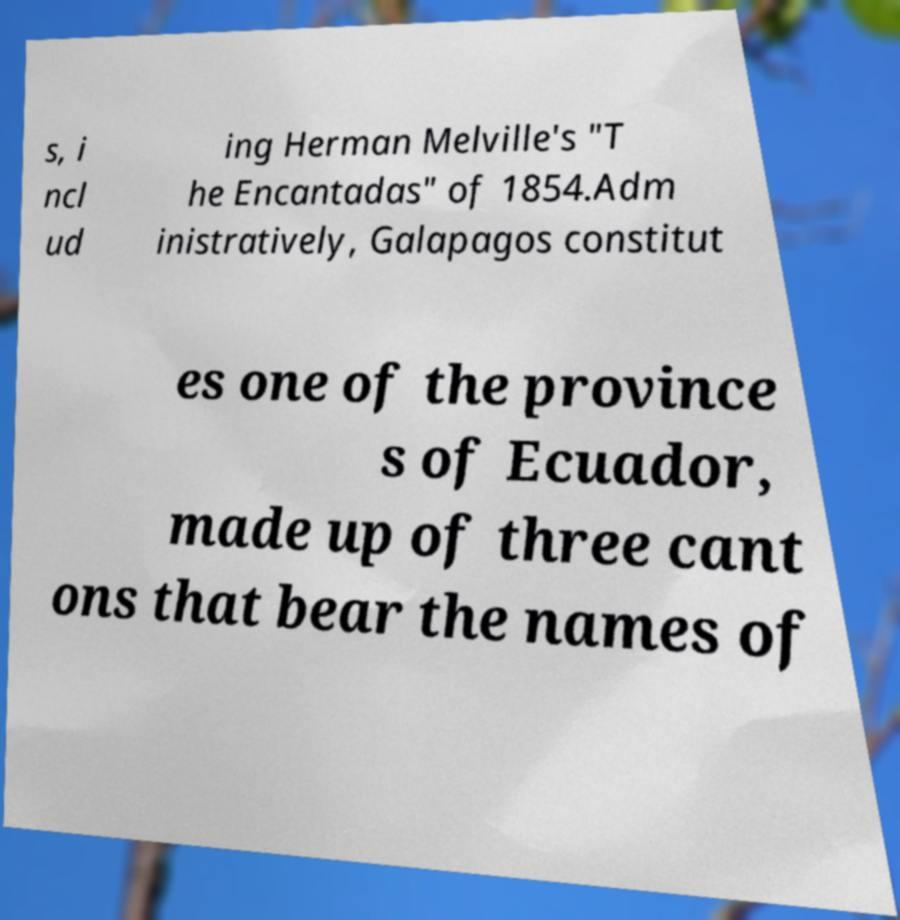Please identify and transcribe the text found in this image. s, i ncl ud ing Herman Melville's "T he Encantadas" of 1854.Adm inistratively, Galapagos constitut es one of the province s of Ecuador, made up of three cant ons that bear the names of 